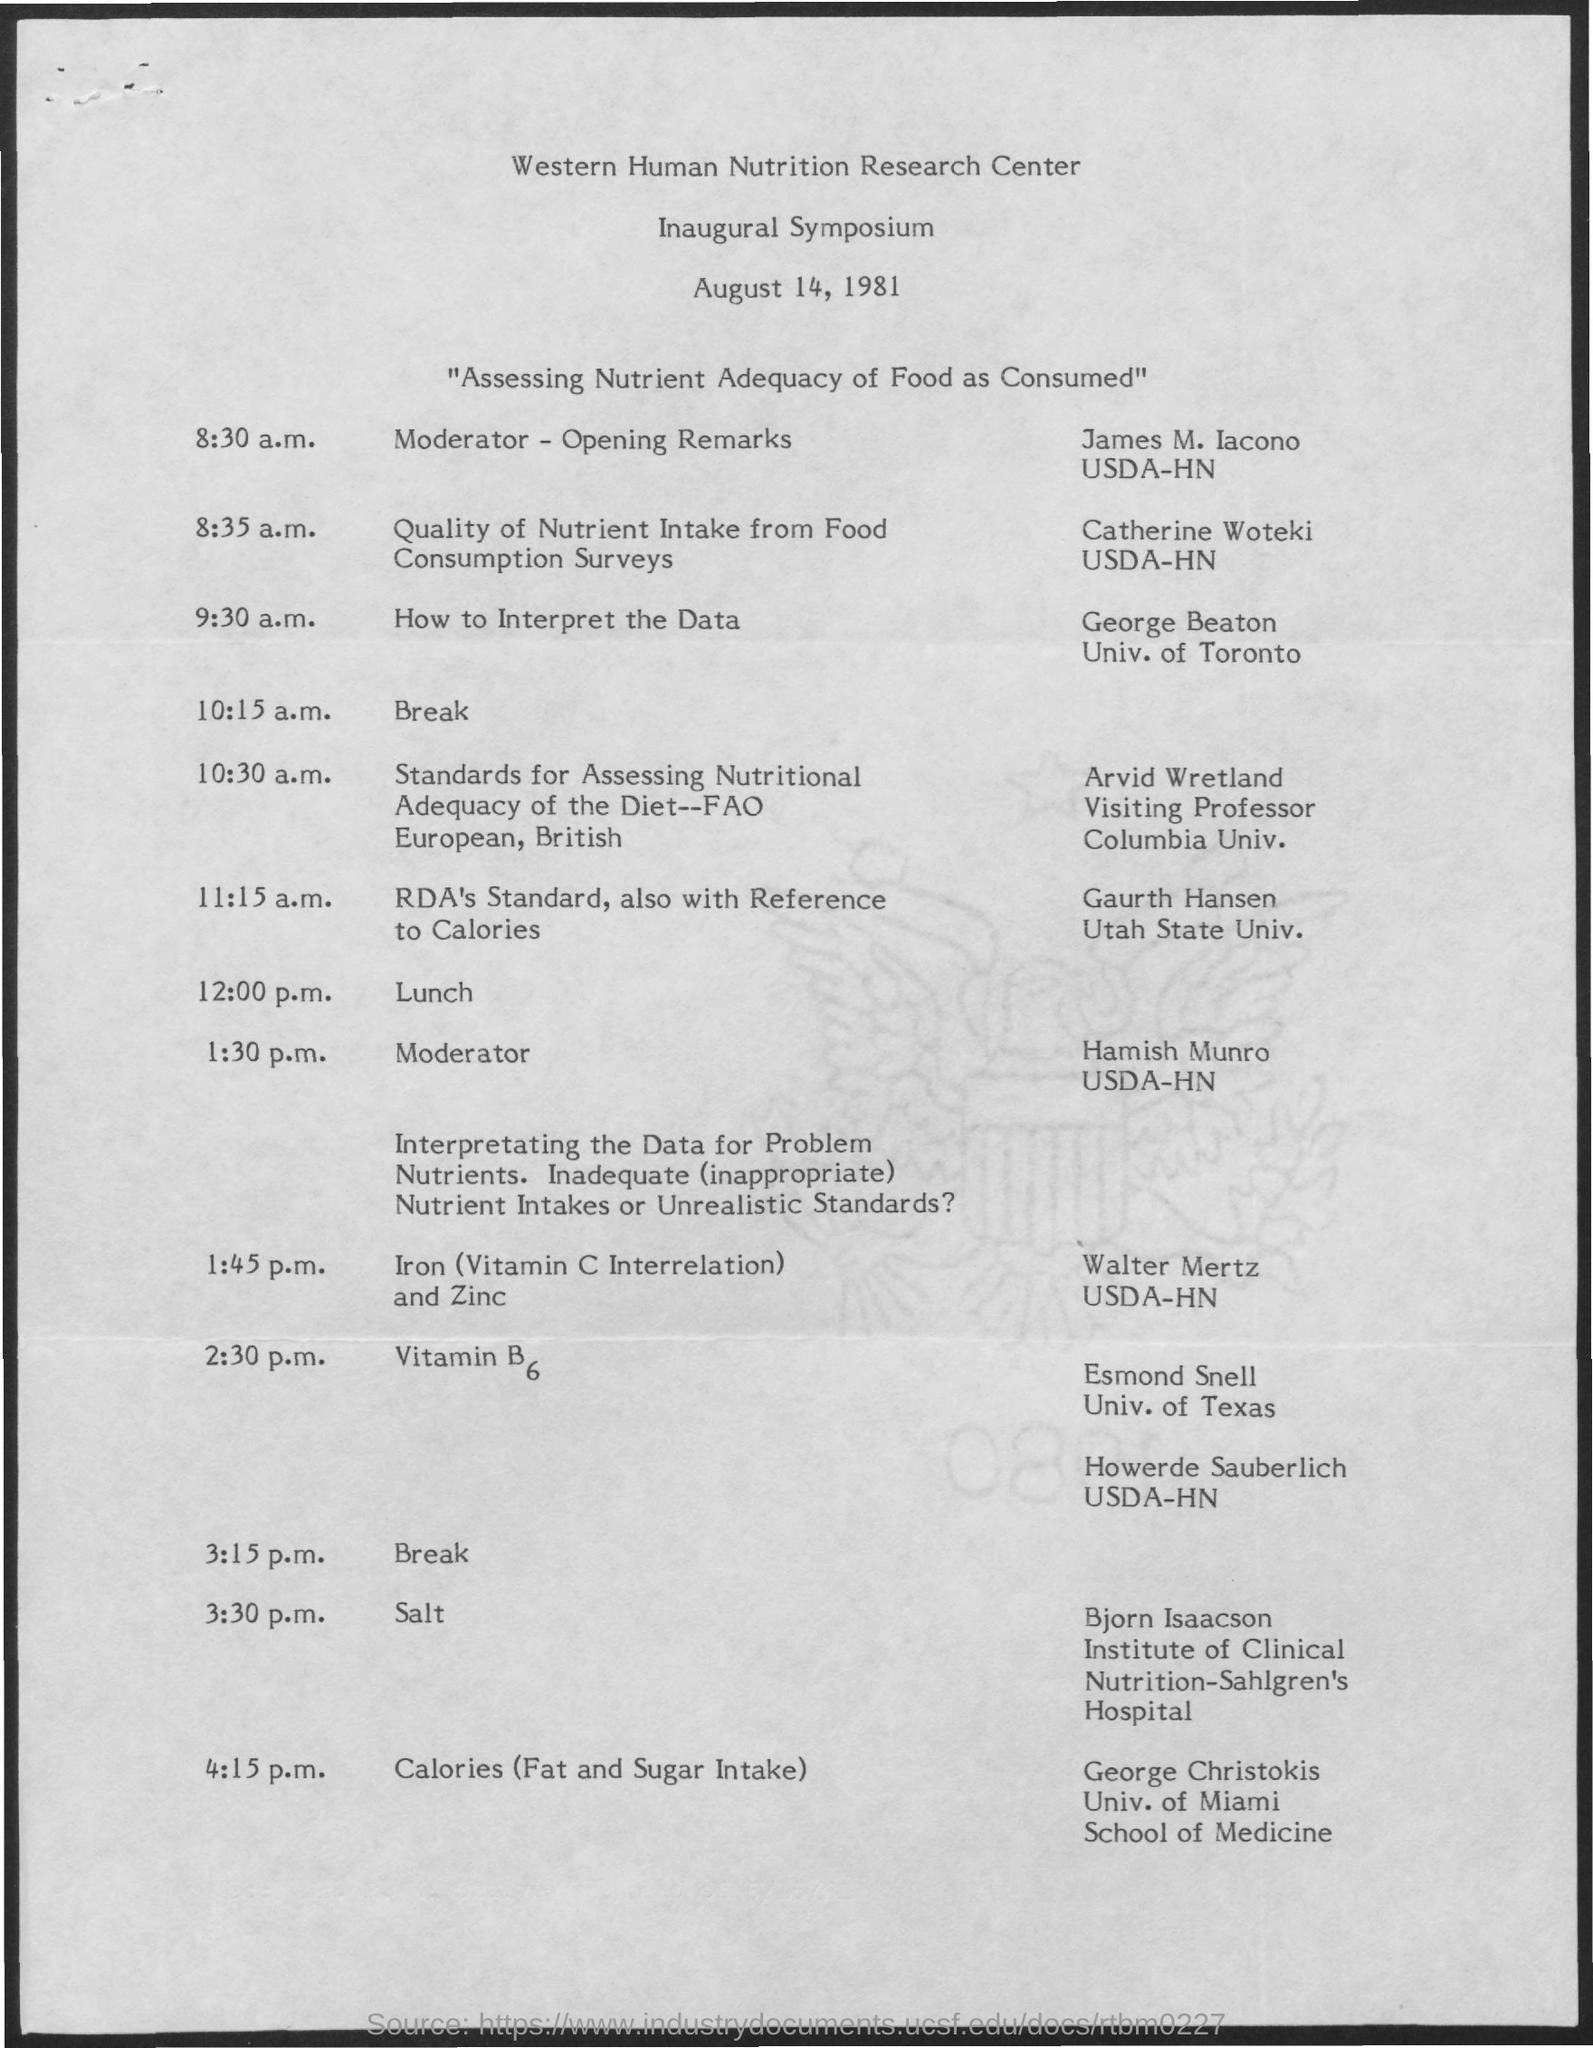Specify some key components in this picture. The opening remarks will take place at 8:30 a.m. The Inaugural Symposium took place on August 14, 1981. The lunch will take place at 12:00 p.m.. 